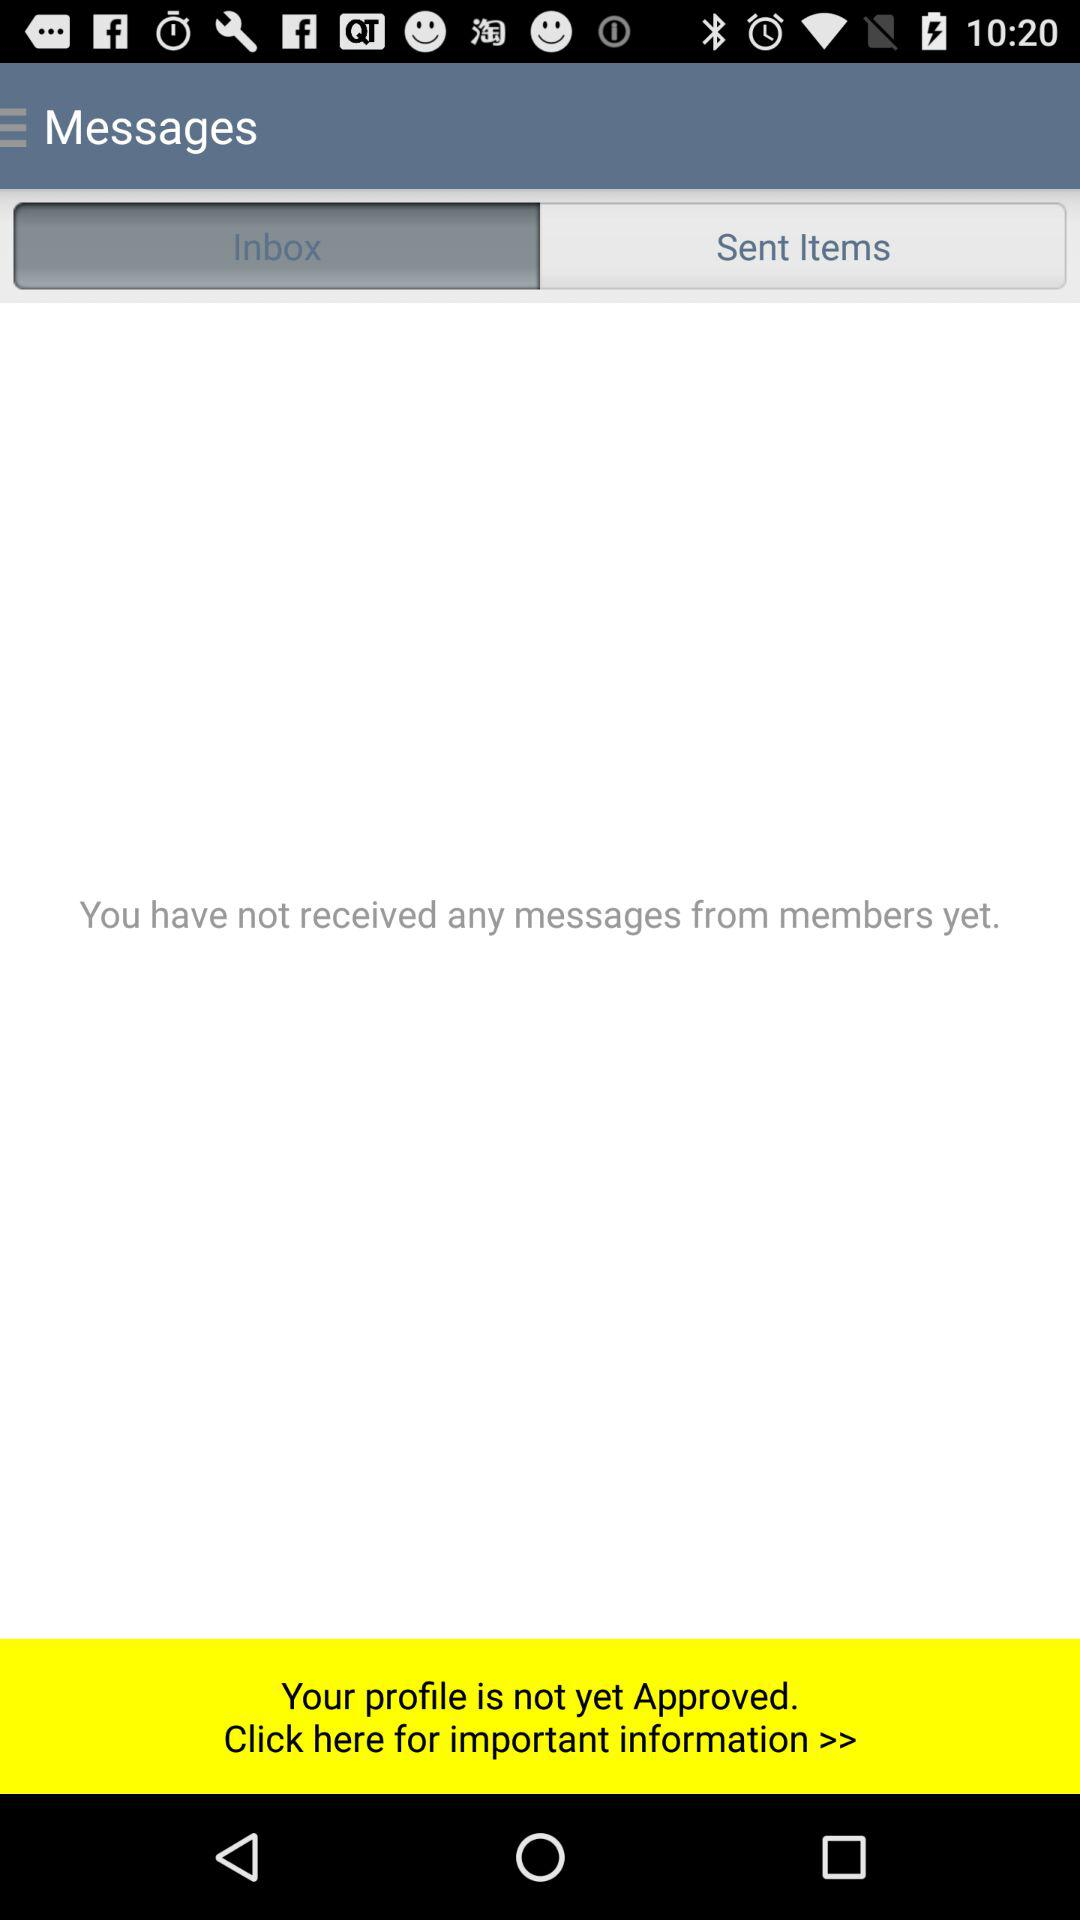Which tab is selected? The selected tab is "Inbox". 